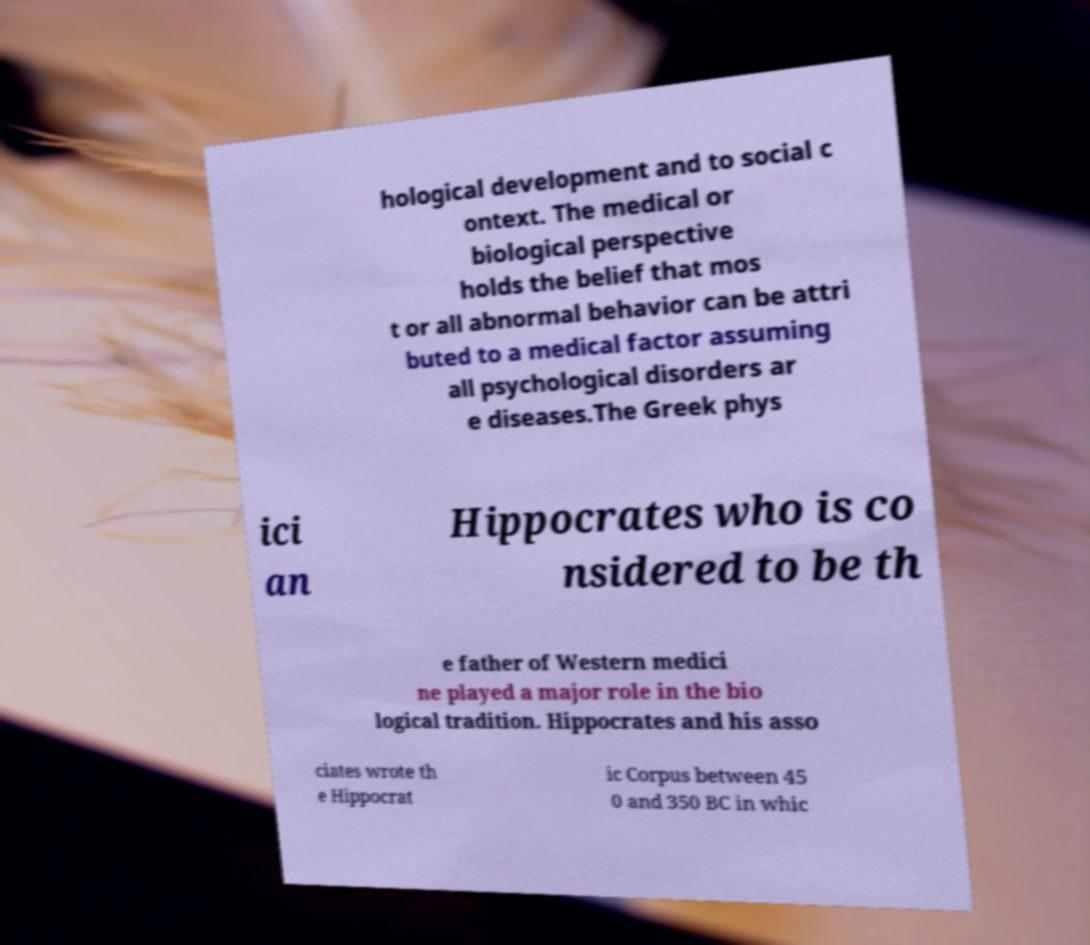Can you accurately transcribe the text from the provided image for me? hological development and to social c ontext. The medical or biological perspective holds the belief that mos t or all abnormal behavior can be attri buted to a medical factor assuming all psychological disorders ar e diseases.The Greek phys ici an Hippocrates who is co nsidered to be th e father of Western medici ne played a major role in the bio logical tradition. Hippocrates and his asso ciates wrote th e Hippocrat ic Corpus between 45 0 and 350 BC in whic 